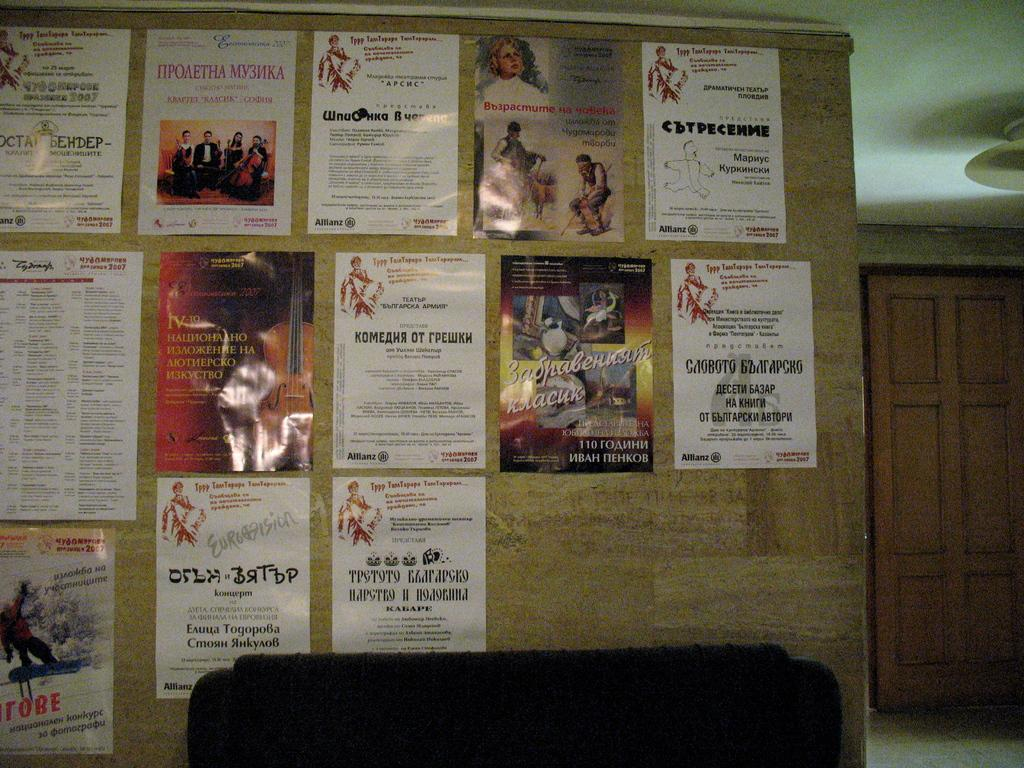<image>
Relay a brief, clear account of the picture shown. A flyer has a cello on it and the Roman numeral IV. 